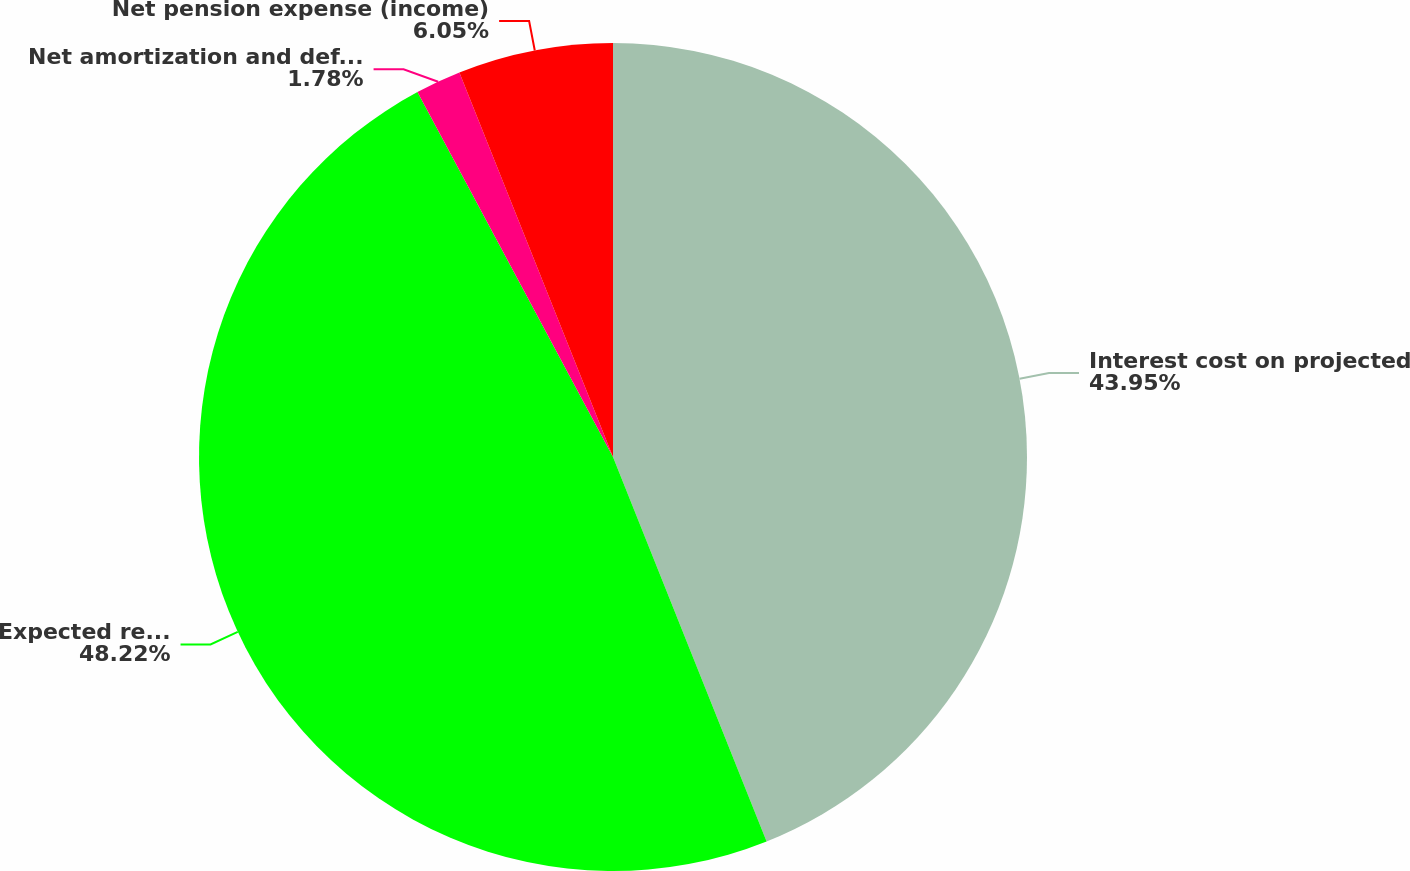Convert chart. <chart><loc_0><loc_0><loc_500><loc_500><pie_chart><fcel>Interest cost on projected<fcel>Expected return on plan assets<fcel>Net amortization and deferral<fcel>Net pension expense (income)<nl><fcel>43.95%<fcel>48.22%<fcel>1.78%<fcel>6.05%<nl></chart> 